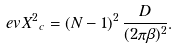Convert formula to latex. <formula><loc_0><loc_0><loc_500><loc_500>\ e v { X ^ { 2 } } _ { c } = ( N - 1 ) ^ { 2 } \, \frac { D } { ( 2 \pi \beta ) ^ { 2 } } .</formula> 